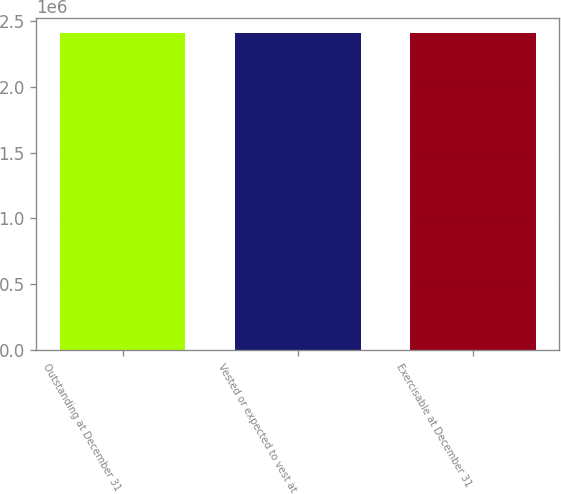Convert chart. <chart><loc_0><loc_0><loc_500><loc_500><bar_chart><fcel>Outstanding at December 31<fcel>Vested or expected to vest at<fcel>Exercisable at December 31<nl><fcel>2.40492e+06<fcel>2.40493e+06<fcel>2.40493e+06<nl></chart> 